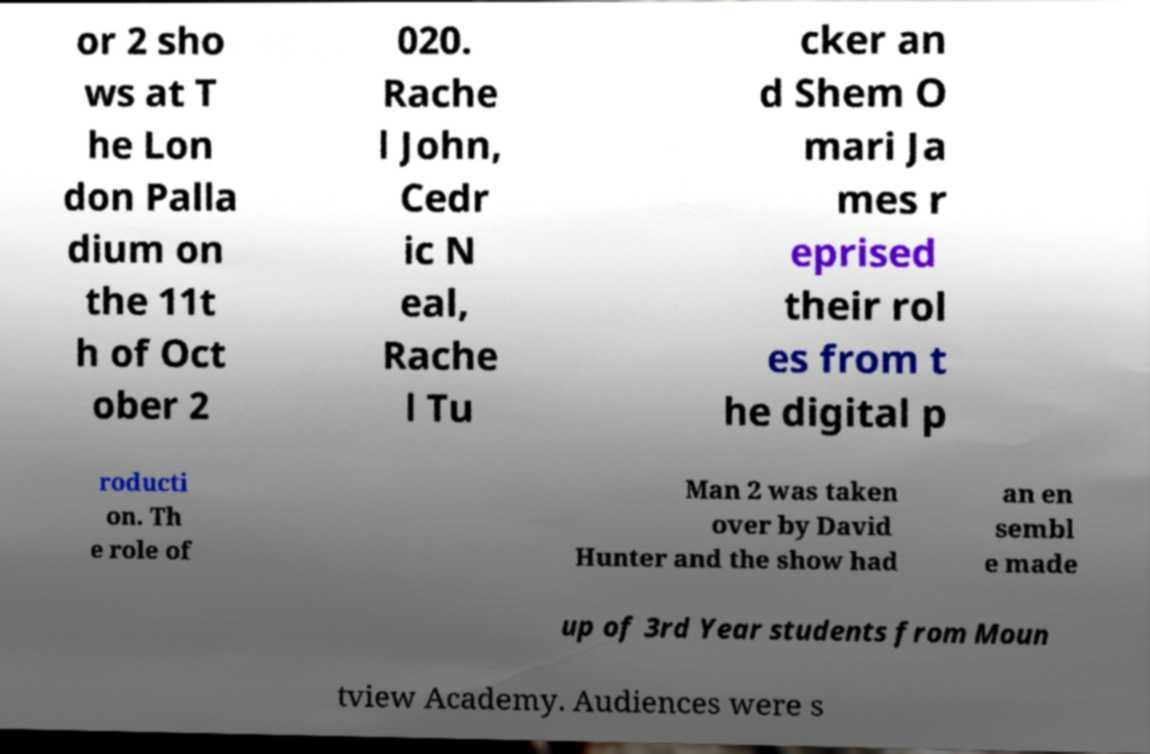For documentation purposes, I need the text within this image transcribed. Could you provide that? or 2 sho ws at T he Lon don Palla dium on the 11t h of Oct ober 2 020. Rache l John, Cedr ic N eal, Rache l Tu cker an d Shem O mari Ja mes r eprised their rol es from t he digital p roducti on. Th e role of Man 2 was taken over by David Hunter and the show had an en sembl e made up of 3rd Year students from Moun tview Academy. Audiences were s 